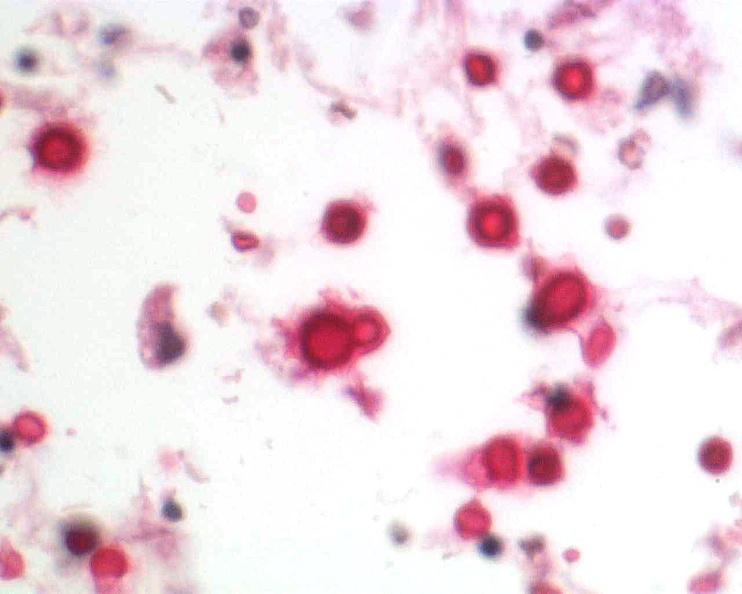do high excellent steroid stain?
Answer the question using a single word or phrase. No 